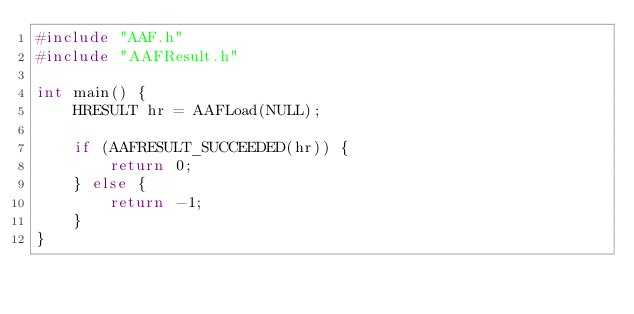Convert code to text. <code><loc_0><loc_0><loc_500><loc_500><_C++_>#include "AAF.h"
#include "AAFResult.h"

int main() {
    HRESULT hr = AAFLoad(NULL);

    if (AAFRESULT_SUCCEEDED(hr)) {
        return 0;
    } else {
        return -1;
    }
}
</code> 